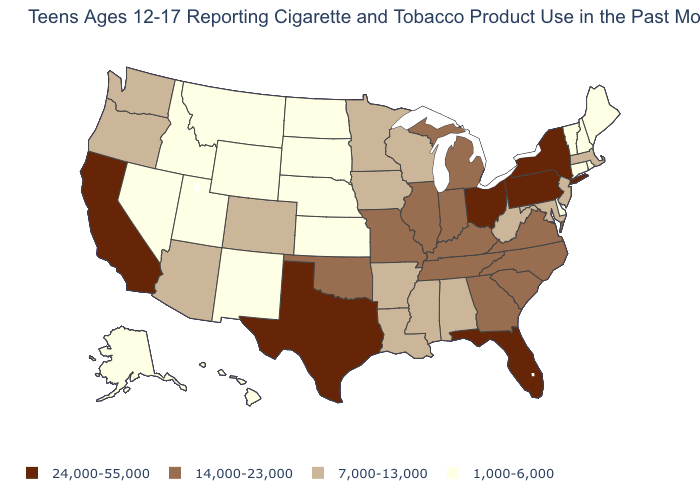Which states have the highest value in the USA?
Keep it brief. California, Florida, New York, Ohio, Pennsylvania, Texas. What is the value of Maine?
Write a very short answer. 1,000-6,000. Among the states that border Pennsylvania , which have the highest value?
Give a very brief answer. New York, Ohio. What is the value of Maine?
Be succinct. 1,000-6,000. Among the states that border New Mexico , does Arizona have the highest value?
Quick response, please. No. Which states hav the highest value in the South?
Give a very brief answer. Florida, Texas. What is the highest value in states that border New York?
Be succinct. 24,000-55,000. How many symbols are there in the legend?
Quick response, please. 4. What is the value of South Dakota?
Concise answer only. 1,000-6,000. Is the legend a continuous bar?
Concise answer only. No. What is the value of Michigan?
Write a very short answer. 14,000-23,000. What is the value of Idaho?
Short answer required. 1,000-6,000. What is the value of South Dakota?
Keep it brief. 1,000-6,000. What is the value of Colorado?
Keep it brief. 7,000-13,000. 